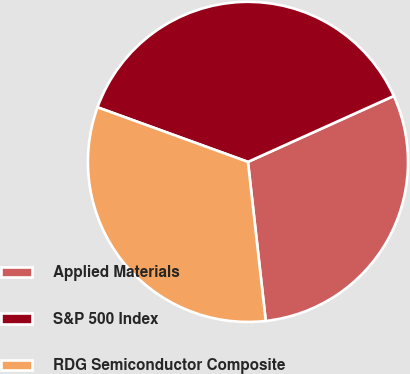Convert chart to OTSL. <chart><loc_0><loc_0><loc_500><loc_500><pie_chart><fcel>Applied Materials<fcel>S&P 500 Index<fcel>RDG Semiconductor Composite<nl><fcel>29.98%<fcel>37.7%<fcel>32.31%<nl></chart> 